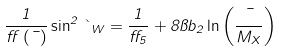Convert formula to latex. <formula><loc_0><loc_0><loc_500><loc_500>\frac { 1 } { \alpha \left ( \mu \right ) } \sin ^ { 2 } \theta _ { W } = \frac { 1 } { \alpha _ { 5 } } + 8 \pi b _ { 2 } \ln \left ( \frac { \mu } { M _ { X } } \right )</formula> 